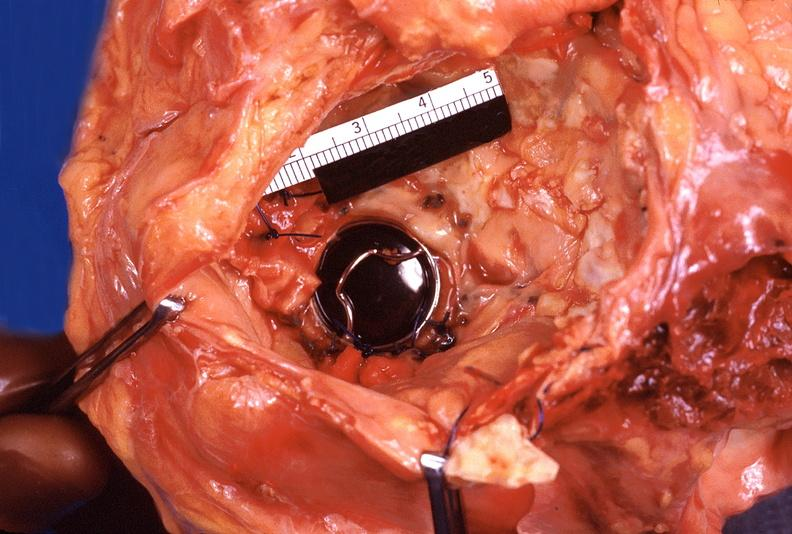what is present?
Answer the question using a single word or phrase. Cardiovascular 